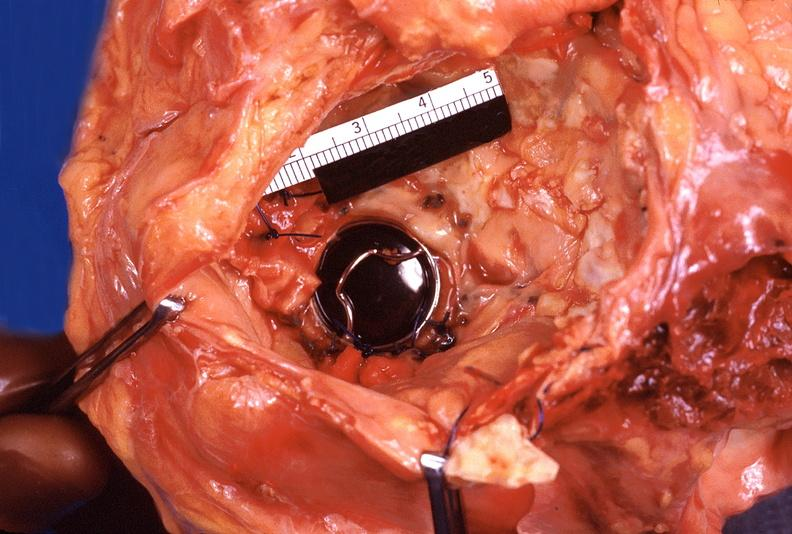what is present?
Answer the question using a single word or phrase. Cardiovascular 